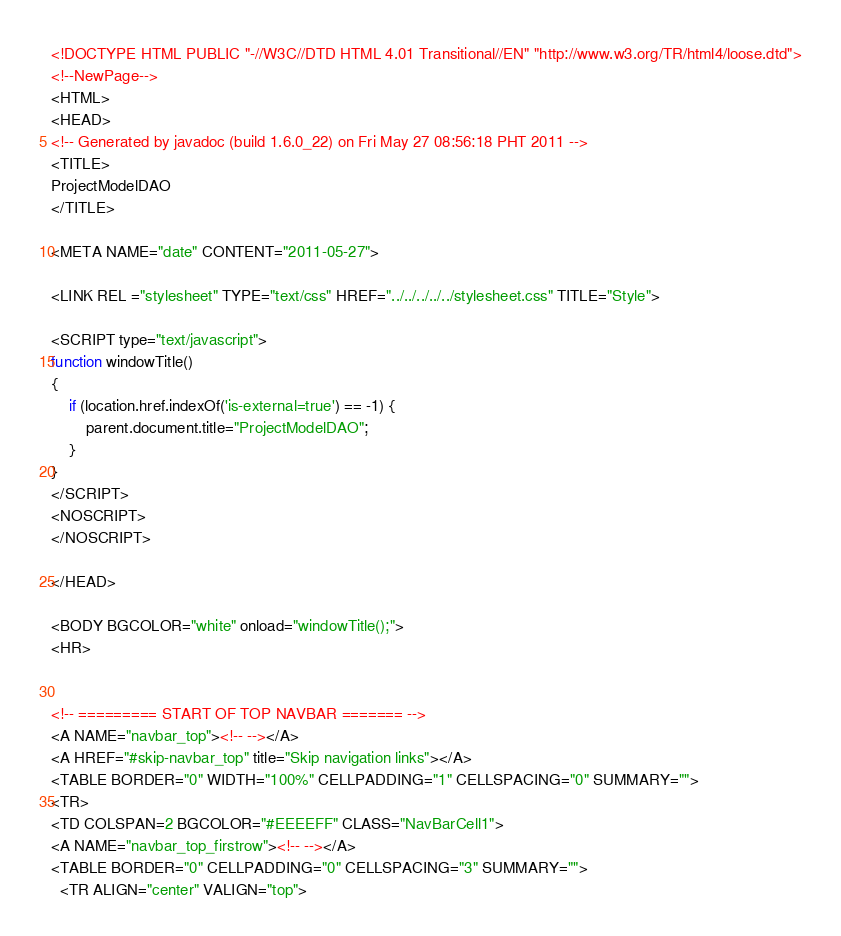Convert code to text. <code><loc_0><loc_0><loc_500><loc_500><_HTML_><!DOCTYPE HTML PUBLIC "-//W3C//DTD HTML 4.01 Transitional//EN" "http://www.w3.org/TR/html4/loose.dtd">
<!--NewPage-->
<HTML>
<HEAD>
<!-- Generated by javadoc (build 1.6.0_22) on Fri May 27 08:56:18 PHT 2011 -->
<TITLE>
ProjectModelDAO
</TITLE>

<META NAME="date" CONTENT="2011-05-27">

<LINK REL ="stylesheet" TYPE="text/css" HREF="../../../../../stylesheet.css" TITLE="Style">

<SCRIPT type="text/javascript">
function windowTitle()
{
    if (location.href.indexOf('is-external=true') == -1) {
        parent.document.title="ProjectModelDAO";
    }
}
</SCRIPT>
<NOSCRIPT>
</NOSCRIPT>

</HEAD>

<BODY BGCOLOR="white" onload="windowTitle();">
<HR>


<!-- ========= START OF TOP NAVBAR ======= -->
<A NAME="navbar_top"><!-- --></A>
<A HREF="#skip-navbar_top" title="Skip navigation links"></A>
<TABLE BORDER="0" WIDTH="100%" CELLPADDING="1" CELLSPACING="0" SUMMARY="">
<TR>
<TD COLSPAN=2 BGCOLOR="#EEEEFF" CLASS="NavBarCell1">
<A NAME="navbar_top_firstrow"><!-- --></A>
<TABLE BORDER="0" CELLPADDING="0" CELLSPACING="3" SUMMARY="">
  <TR ALIGN="center" VALIGN="top"></code> 